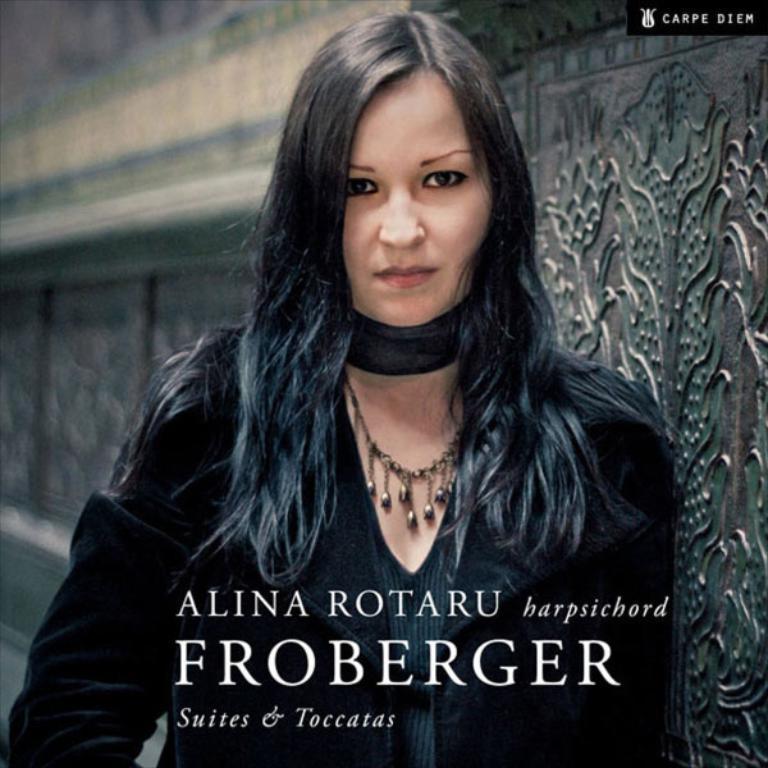Please provide a concise description of this image. In the center of the image we can see a lady standing. She is wearing a black dress. In the background there is a wall. At the bottom we can see text. 